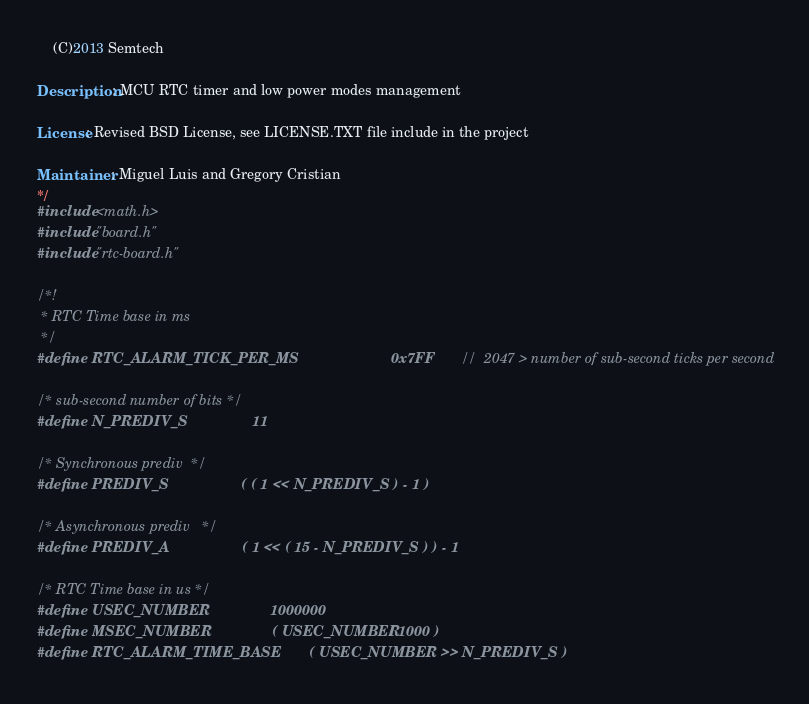Convert code to text. <code><loc_0><loc_0><loc_500><loc_500><_C_>    (C)2013 Semtech

Description: MCU RTC timer and low power modes management

License: Revised BSD License, see LICENSE.TXT file include in the project

Maintainer: Miguel Luis and Gregory Cristian
*/
#include <math.h>
#include "board.h"
#include "rtc-board.h"

/*!
 * RTC Time base in ms
 */
#define RTC_ALARM_TICK_PER_MS                       0x7FF           //  2047 > number of sub-second ticks per second

/* sub-second number of bits */
#define N_PREDIV_S                11

/* Synchronous prediv  */
#define PREDIV_S                  ( ( 1 << N_PREDIV_S ) - 1 )

/* Asynchronous prediv   */
#define PREDIV_A                  ( 1 << ( 15 - N_PREDIV_S ) ) - 1

/* RTC Time base in us */
#define USEC_NUMBER               1000000
#define MSEC_NUMBER               ( USEC_NUMBER / 1000 )
#define RTC_ALARM_TIME_BASE       ( USEC_NUMBER >> N_PREDIV_S )
</code> 